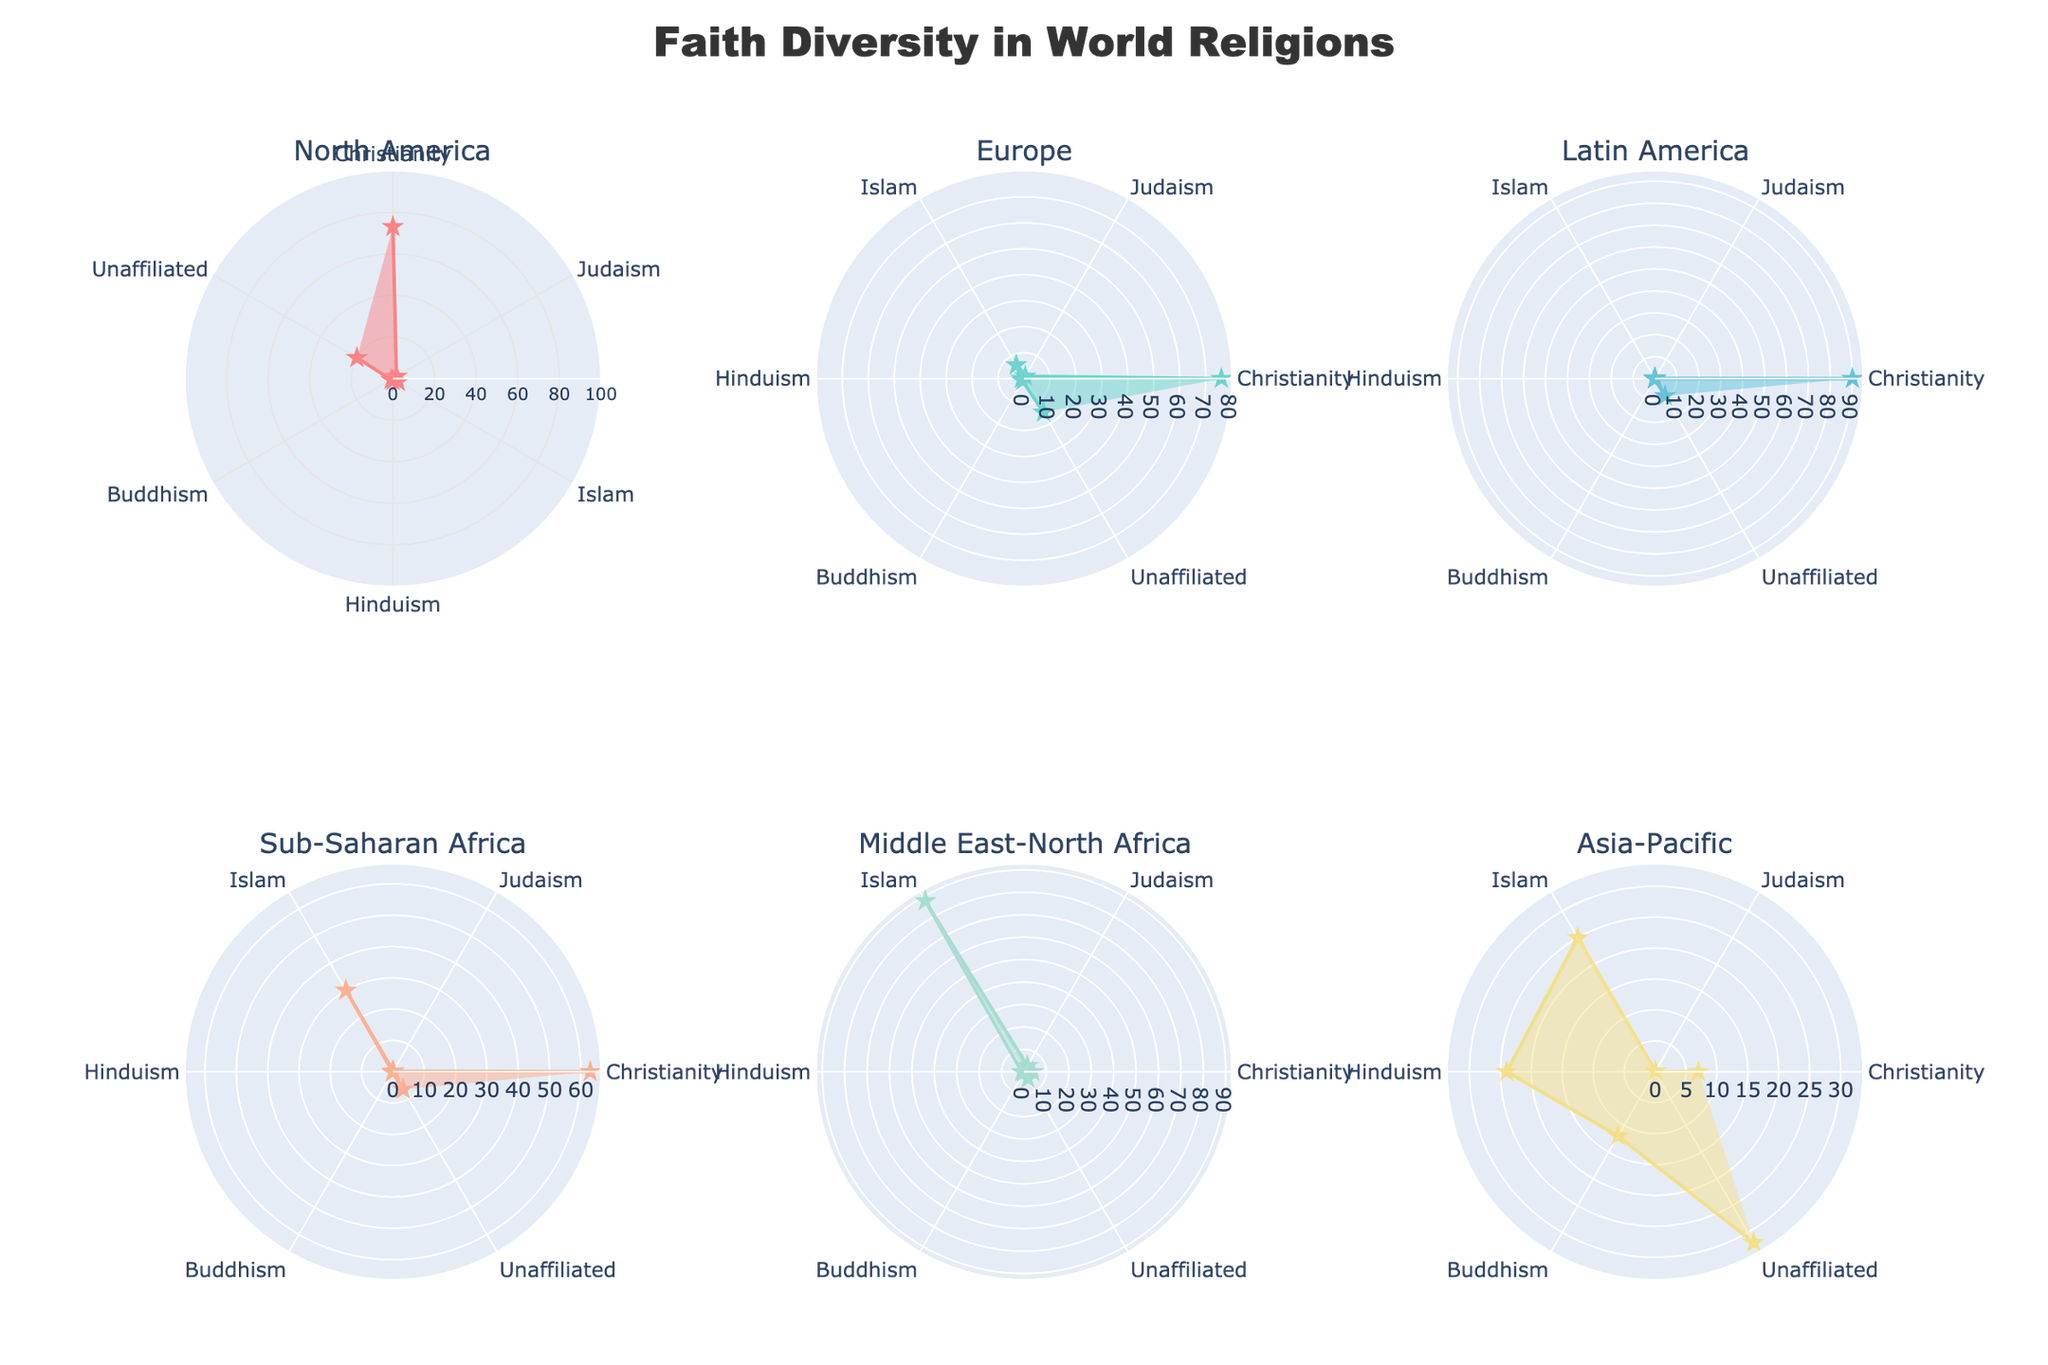What is the title of the figure? The title is typically placed at the top of the figure and clearly labeled.
Answer: Faith Diversity in World Religions Which region has the highest adherence to Christianity? By examining the radial spread for Christianity, Latin America shows the highest adherence.
Answer: Latin America What percentage of people in Asia-Pacific are unaffiliated with any religion? Look for the segment labeled "Unaffiliated" in the Asia-Pacific subplot and note the value.
Answer: 31.9% Compare the adherence to Islam in Europe and Sub-Saharan Africa. Which region has a higher percentage? Identify the "Islam" segment in both the Europe and Sub-Saharan Africa subplots. Europe shows 6%, while Sub-Saharan Africa shows 30%.
Answer: Sub-Saharan Africa Which region has the most diverse adherence among the five listed religions? Diversity is indicated by more equal distribution among the categories; Asia-Pacific has relatively balanced adherence across multiple religions.
Answer: Asia-Pacific How does the percentage of individuals practicing Judaism in North America compare to that in the Middle East-North Africa? Look at the "Judaism" segment in both regions. North America has 2%, whereas Middle East-North Africa has 3%.
Answer: Middle East-North Africa What is the sum of adherence percentages for Islam and Buddhism in Sub-Saharan Africa? Add 30% (Islam) and 0.2% (Buddhism) as listed in the Sub-Saharan Africa region.
Answer: 30.2% In which region is Hinduism's adherence highest? Observe the "Hinduism" segments and find the highest value in the Asia-Pacific subplot.
Answer: Asia-Pacific What religion has the smallest percentage of adherence across all regions? Compare the lowest adherence values for each religion across all subplots, and Judaism generally has the smallest values.
Answer: Judaism Which religion shows approximately equal adherence (around 1%) in all regions? Scan for segments where percentages hover around 1% across different regions and notice that Buddhism has values close to 1% in most regions.
Answer: Buddhism 